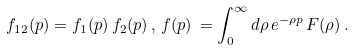<formula> <loc_0><loc_0><loc_500><loc_500>f _ { 1 2 } ( p ) = f _ { 1 } ( p ) \, f _ { 2 } ( p ) \, , \, f ( p ) \, = \int _ { 0 } ^ { \infty } d \rho \, e ^ { - \rho p } \, F ( \rho ) \, .</formula> 